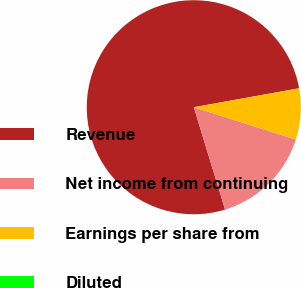Convert chart. <chart><loc_0><loc_0><loc_500><loc_500><pie_chart><fcel>Revenue<fcel>Net income from continuing<fcel>Earnings per share from<fcel>Diluted<nl><fcel>76.89%<fcel>15.39%<fcel>7.7%<fcel>0.02%<nl></chart> 